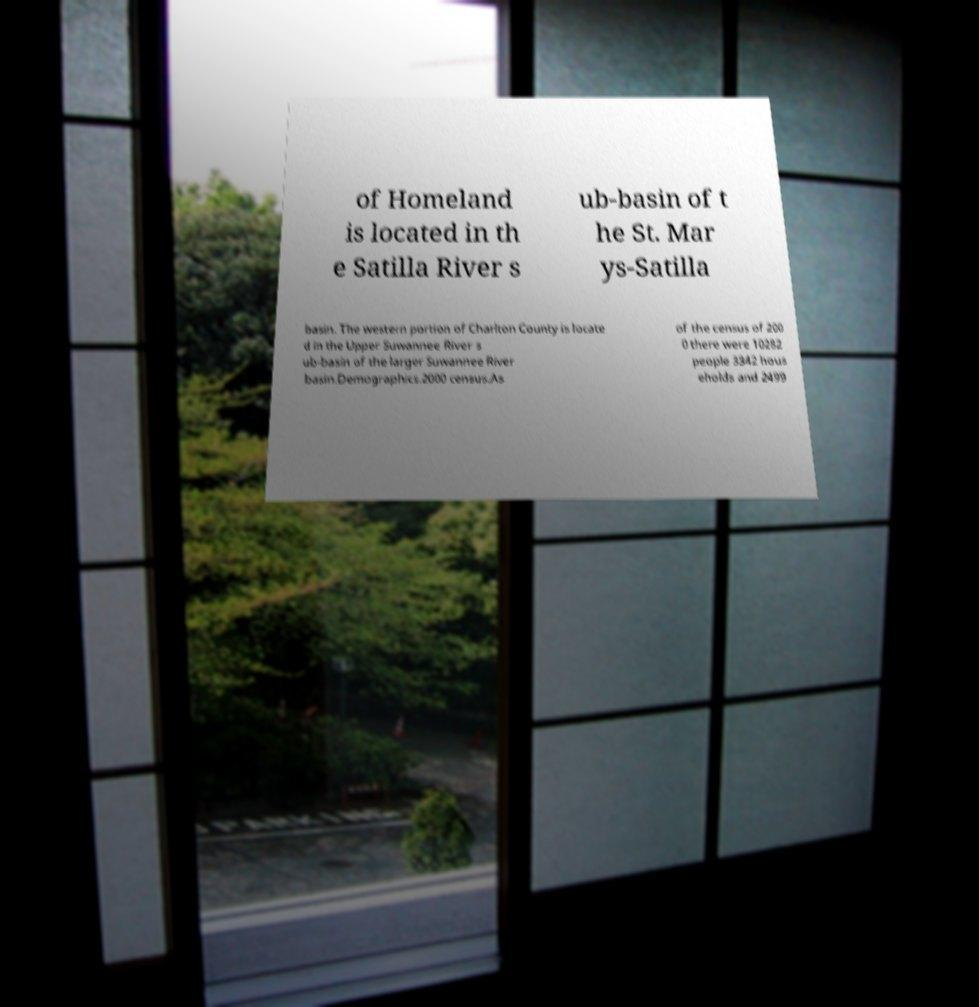There's text embedded in this image that I need extracted. Can you transcribe it verbatim? of Homeland is located in th e Satilla River s ub-basin of t he St. Mar ys-Satilla basin. The western portion of Charlton County is locate d in the Upper Suwannee River s ub-basin of the larger Suwannee River basin.Demographics.2000 census.As of the census of 200 0 there were 10282 people 3342 hous eholds and 2499 